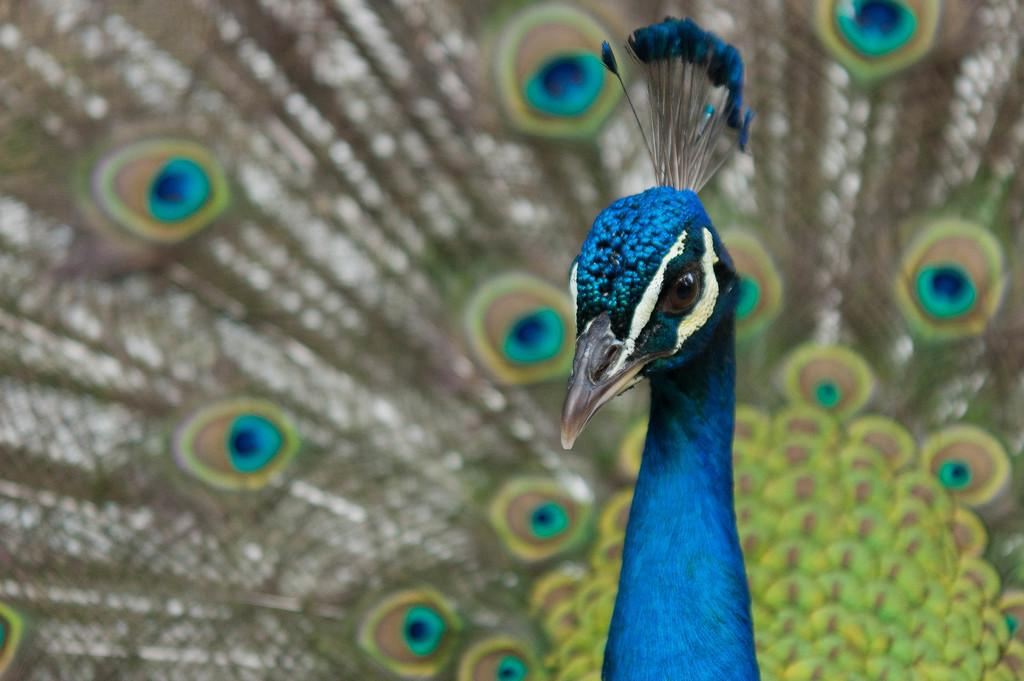What type of animal is in the image? There is a peacock in the image. What type of band is playing in the background of the image? There is no band present in the image; it features a peacock. What type of station is visible in the image? There is no station present in the image; it features a peacock. 